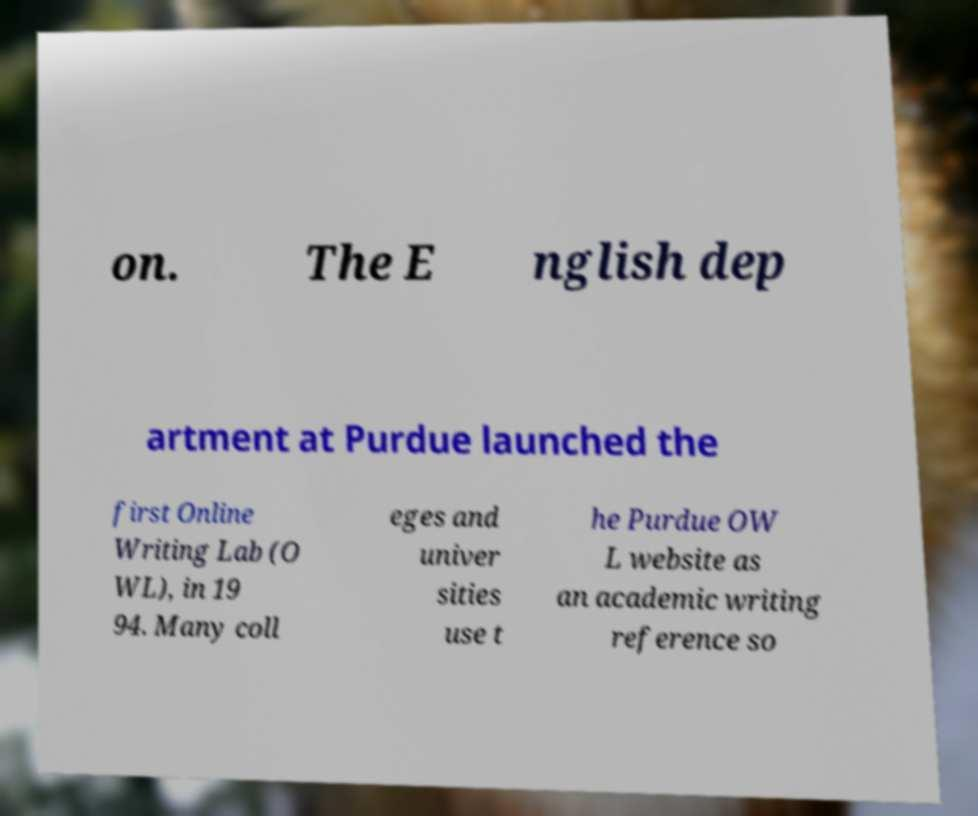Can you read and provide the text displayed in the image?This photo seems to have some interesting text. Can you extract and type it out for me? on. The E nglish dep artment at Purdue launched the first Online Writing Lab (O WL), in 19 94. Many coll eges and univer sities use t he Purdue OW L website as an academic writing reference so 